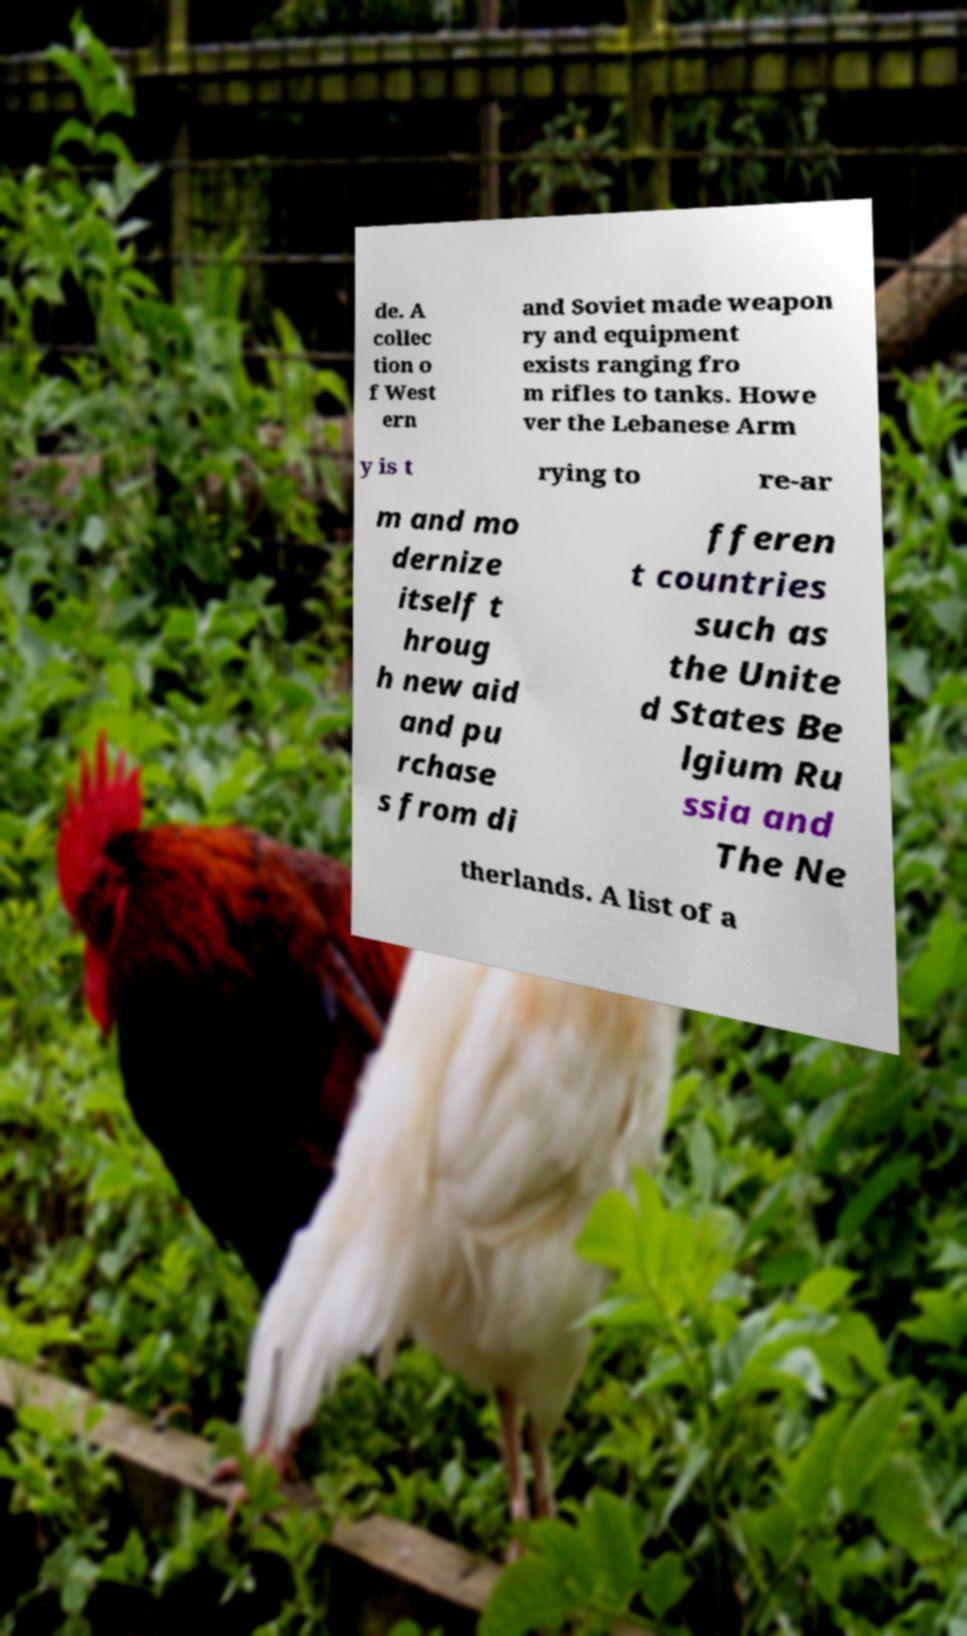Please identify and transcribe the text found in this image. de. A collec tion o f West ern and Soviet made weapon ry and equipment exists ranging fro m rifles to tanks. Howe ver the Lebanese Arm y is t rying to re-ar m and mo dernize itself t hroug h new aid and pu rchase s from di fferen t countries such as the Unite d States Be lgium Ru ssia and The Ne therlands. A list of a 